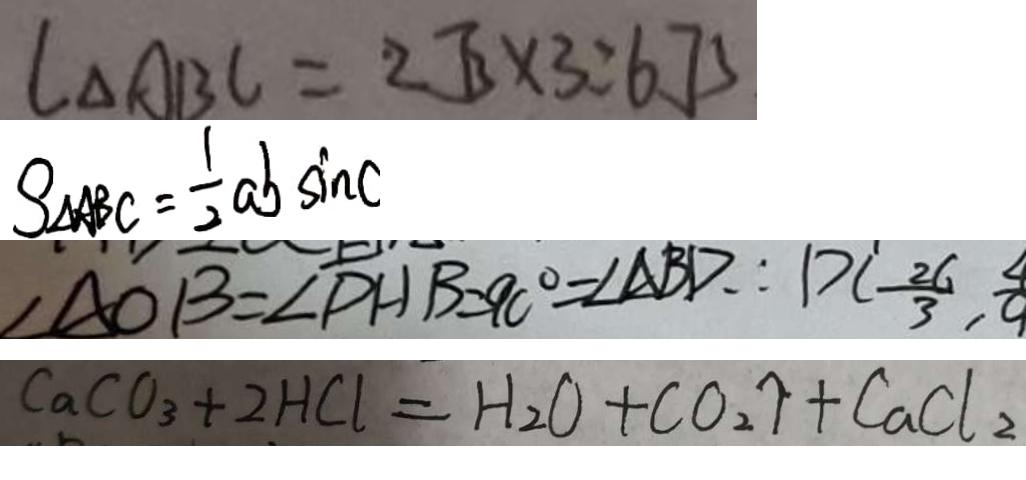<formula> <loc_0><loc_0><loc_500><loc_500>l _ { \Delta A B C } = 2 \sqrt { 3 } \times 3 = 6 . 7 5 
 S _ { \Delta A B C } = \frac { 1 } { 2 } a b \sin C 
 \angle A O B = \angle D H B = 9 0 ^ { \circ } = \angle A B D \therefore D C - \frac { 2 6 } { 3 } , \frac { 4 } { 9 } 
 C a C O _ { 3 } + 2 H C l = H _ { 2 } O + C O _ { 2 } \uparrow + C a C l _ { 2 }</formula> 